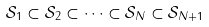Convert formula to latex. <formula><loc_0><loc_0><loc_500><loc_500>\mathcal { S } _ { 1 } \subset \mathcal { S } _ { 2 } \subset \cdots \subset \mathcal { S } _ { N } \subset \mathcal { S } _ { N + 1 } \,</formula> 